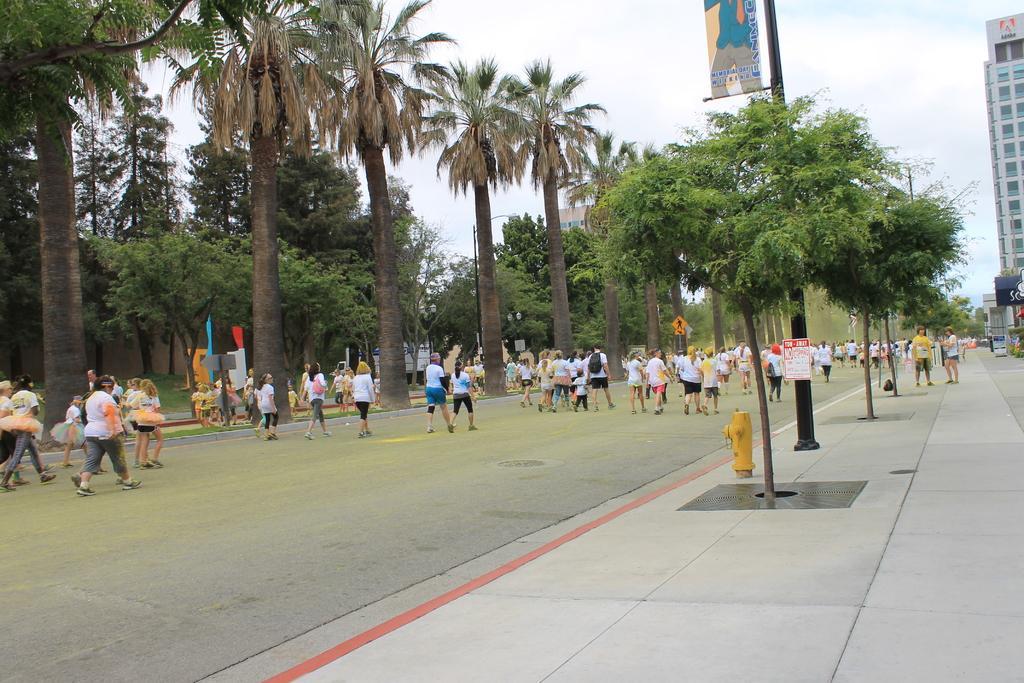Describe this image in one or two sentences. This is an outside view. On the right side, I can see the footpath on which few trees and poles are placed and also I can see a yellow color fire hydrant. On the left side, I can see many people are wearing t-shirts, shirts and walking on the road. On the other side of the road, I can see many trees. In the background there are some buildings. At the top, I can see in the sky. 